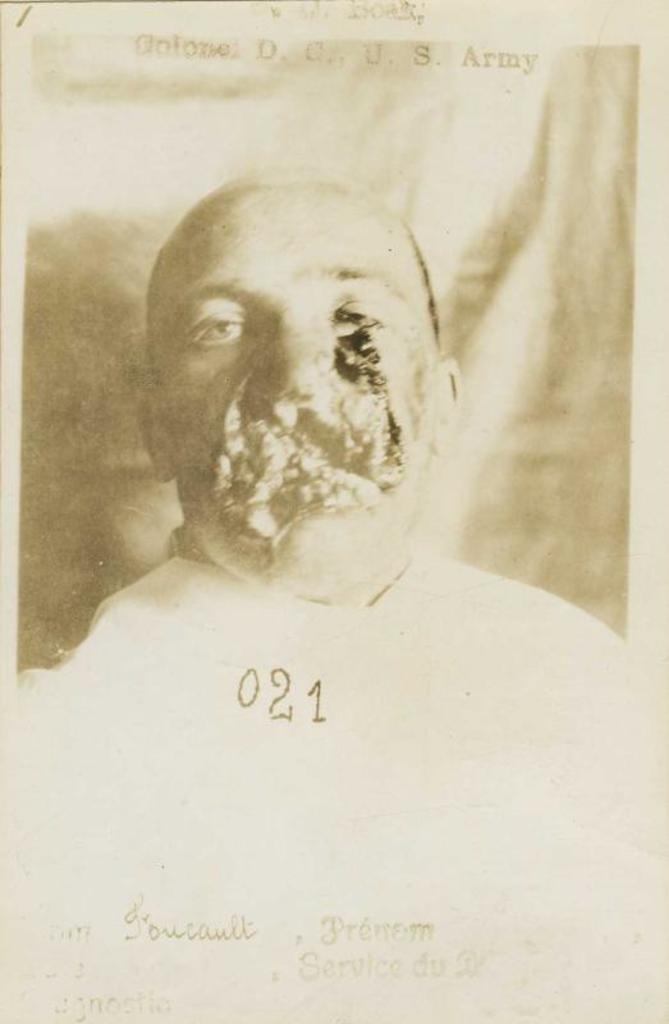Who is present in the image? There is a man in the image. What is the man wearing? The man is wearing a white shirt. How many kittens are sitting on the notebook in the image? There are no kittens or notebooks present in the image. What type of record is the man holding in the image? There is no record present in the image. 